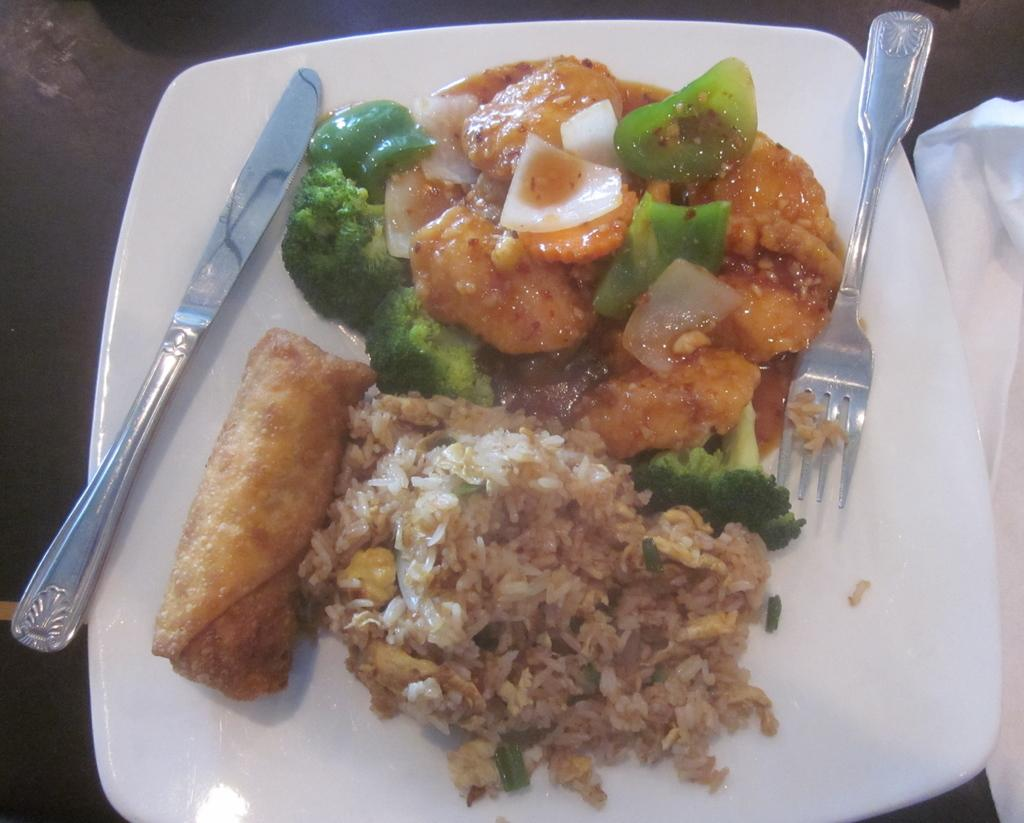What is located at the bottom of the image? There is a table at the bottom of the image. What is placed on the table? There is a plate, paper, food, a spoon, a fork, and a knife on the table. What type of utensils are present on the table? There is a spoon, a fork, and a knife on the table. What type of rod can be seen attached to the plate in the image? There is no rod present in the image; it only features a plate, paper, food, and utensils on the table. 